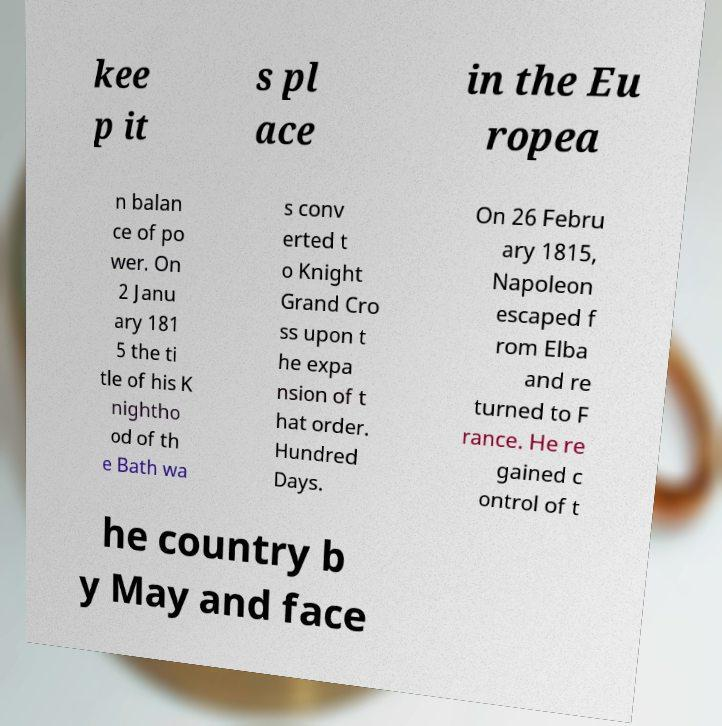Can you accurately transcribe the text from the provided image for me? kee p it s pl ace in the Eu ropea n balan ce of po wer. On 2 Janu ary 181 5 the ti tle of his K nightho od of th e Bath wa s conv erted t o Knight Grand Cro ss upon t he expa nsion of t hat order. Hundred Days. On 26 Febru ary 1815, Napoleon escaped f rom Elba and re turned to F rance. He re gained c ontrol of t he country b y May and face 